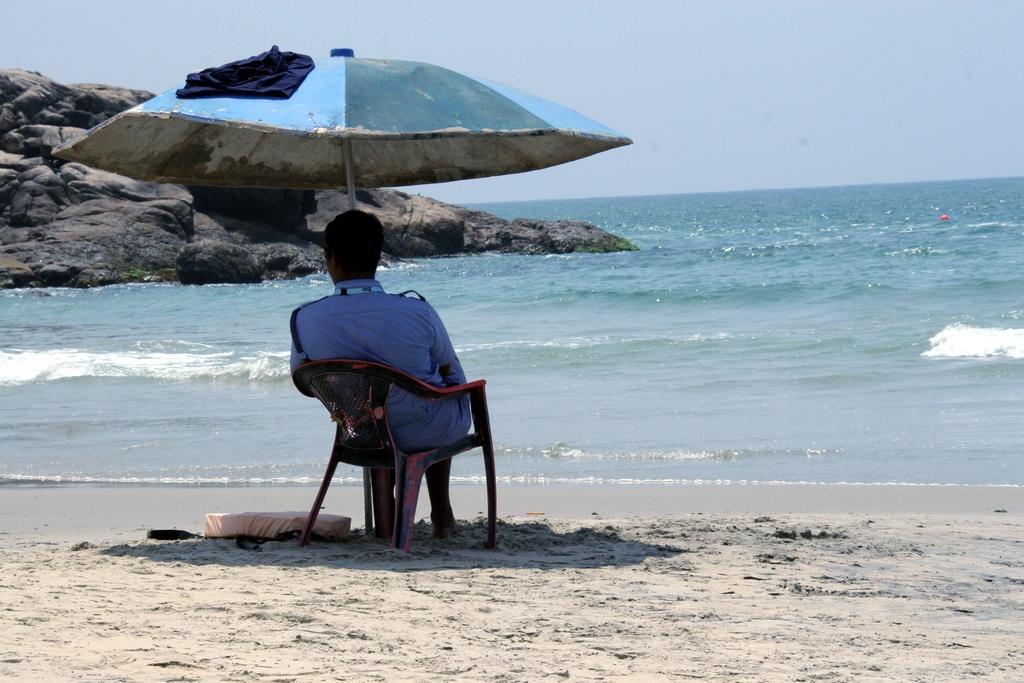In one or two sentences, can you explain what this image depicts? In the foreground I can see a person is sitting on a chair under the umbrella hut in front of the ocean and a rock. At the top I can see the sky. This image is taken may be on the sandy beach. 